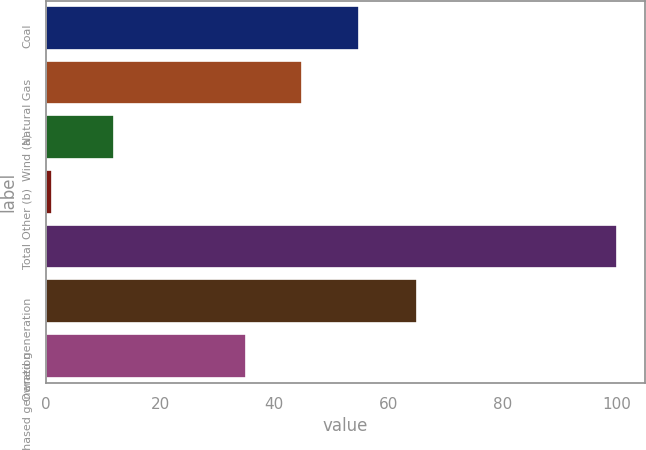<chart> <loc_0><loc_0><loc_500><loc_500><bar_chart><fcel>Coal<fcel>Natural Gas<fcel>Wind (a)<fcel>Other (b)<fcel>Total<fcel>Owned generation<fcel>Purchased generation<nl><fcel>54.8<fcel>44.9<fcel>12<fcel>1<fcel>100<fcel>65<fcel>35<nl></chart> 